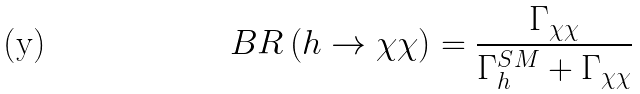<formula> <loc_0><loc_0><loc_500><loc_500>B R \left ( h \rightarrow \chi \chi \right ) = \frac { \Gamma _ { \chi \chi } } { \Gamma _ { h } ^ { S M } + \Gamma _ { \chi \chi } }</formula> 